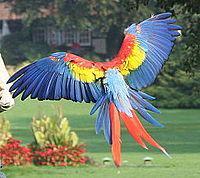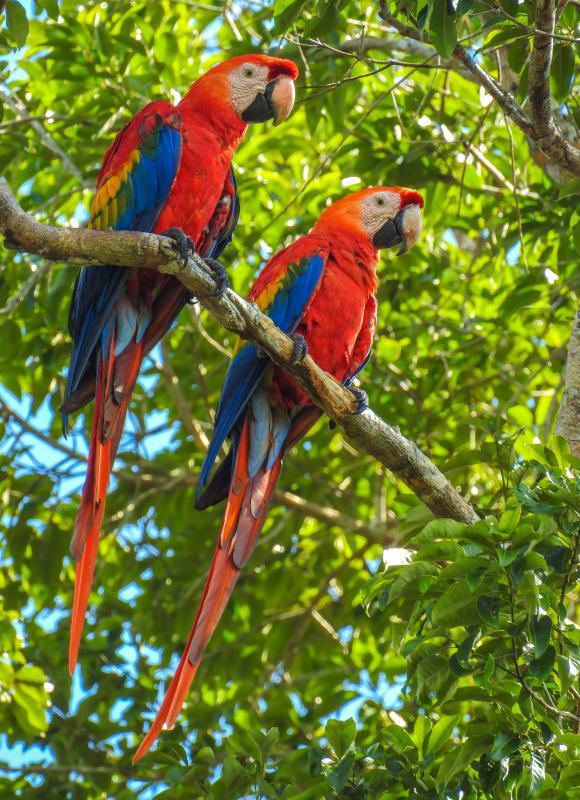The first image is the image on the left, the second image is the image on the right. Evaluate the accuracy of this statement regarding the images: "At least one of the birds is flying.". Is it true? Answer yes or no. Yes. 